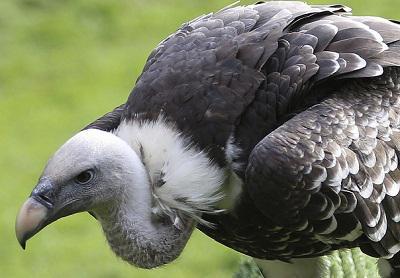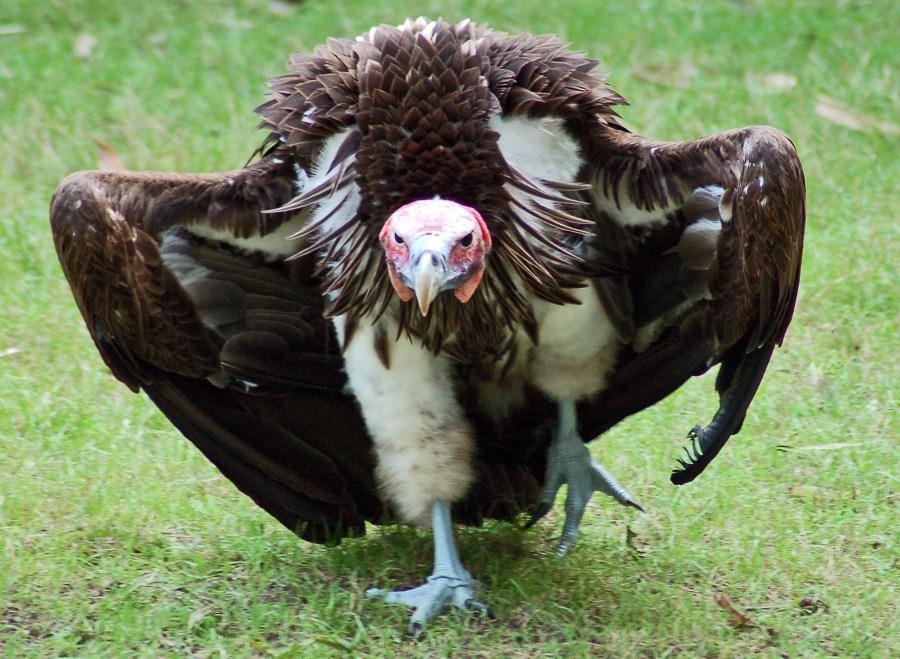The first image is the image on the left, the second image is the image on the right. Considering the images on both sides, is "The entire bird is visible in the image on the right." valid? Answer yes or no. Yes. 